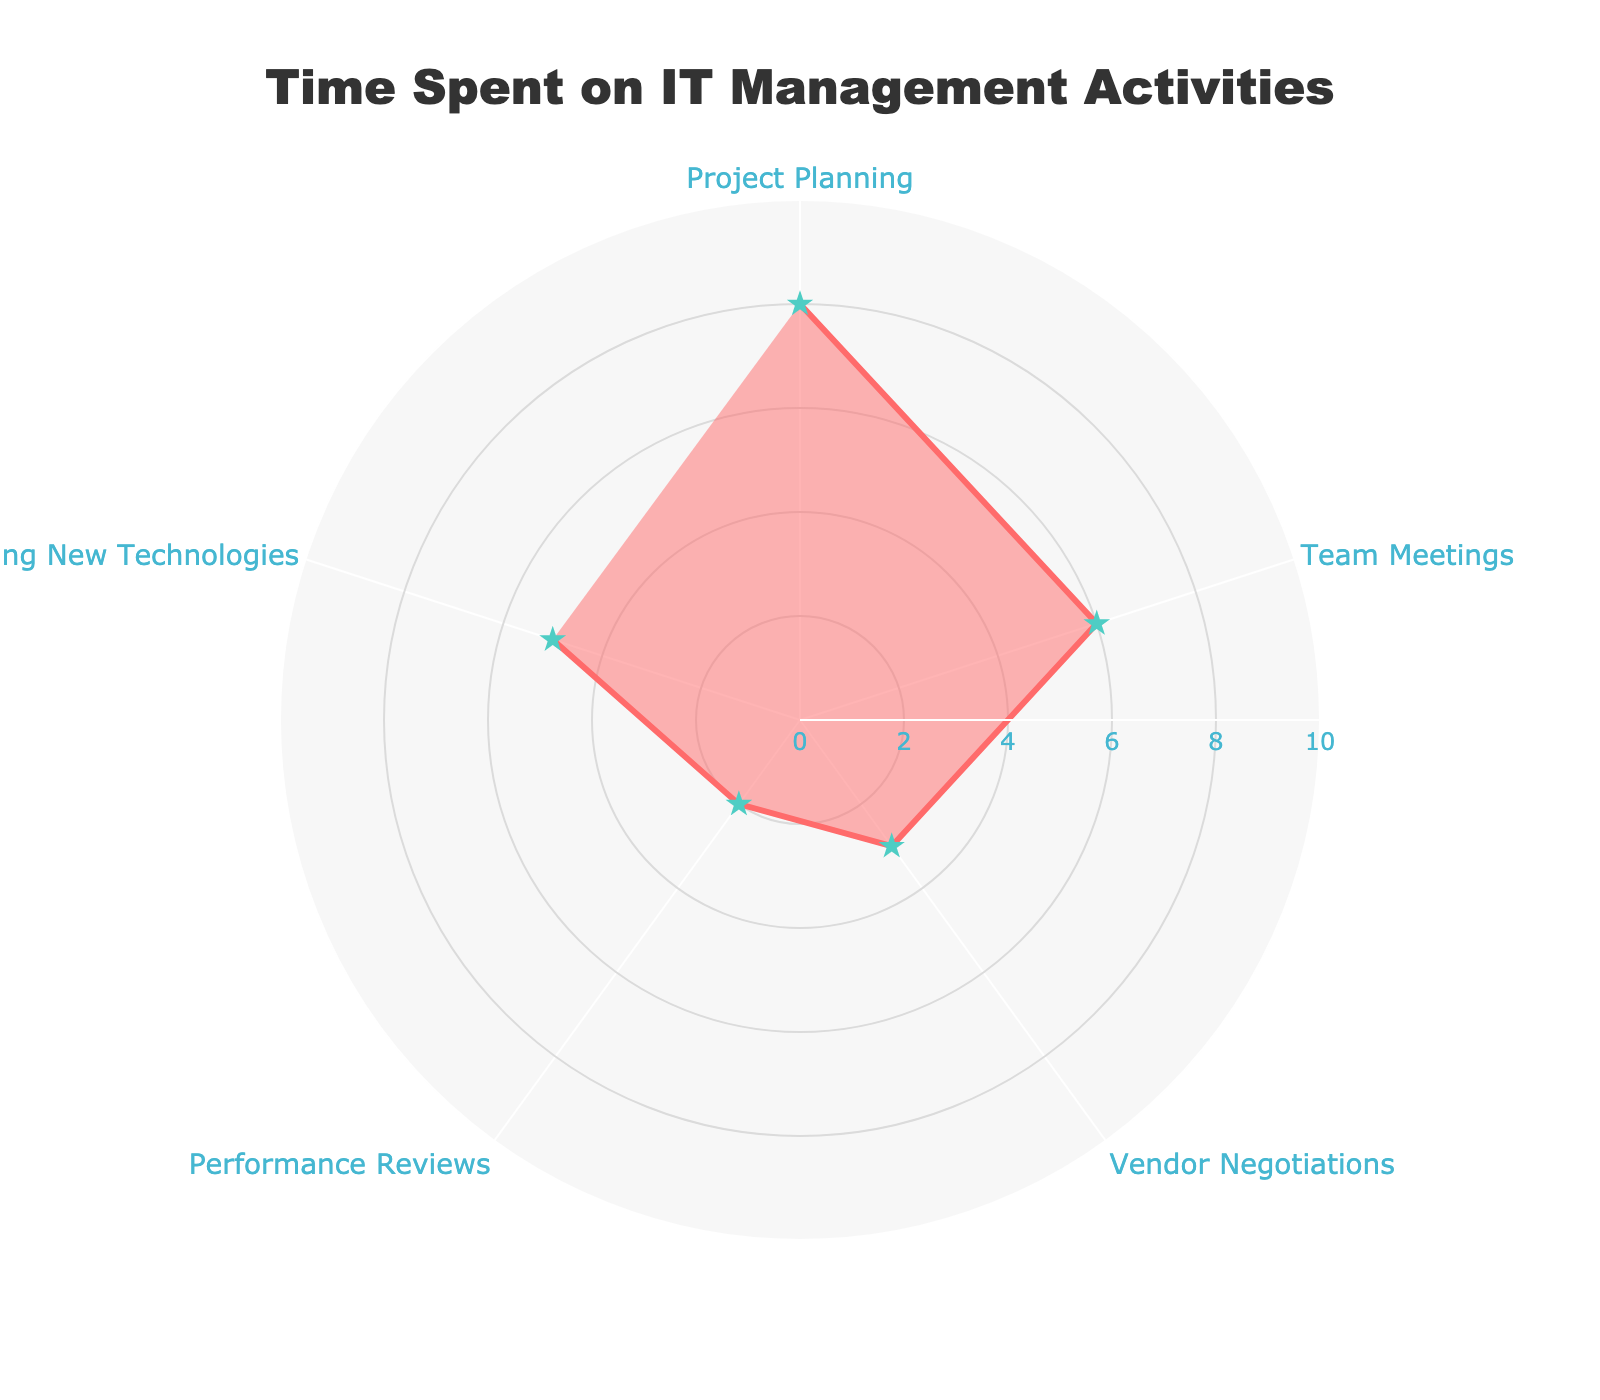What is the title of the radar chart? The title is positioned at the top center of the radar chart. It provides an overview of what the chart represents. By reading the title, we can quickly understand the context of the data displayed.
Answer: Time Spent on IT Management Activities What activity has the highest time spent per week? By looking at the values around the radar chart, you can identify which activity has the largest value. It should be the point reaching the furthest from the center.
Answer: Project Planning What is the range of the radial axis in the chart? The radial axis range is visible on the chart, showing the minimum and maximum values that can be represented.
Answer: 0 to 10 Which two activities have a combined total time spent of 14 hours per week? Find two sections of the radar chart where the sum of their values equals 14. You can do this by examining the individual values and mentally adding them together.
Answer: Project Planning and Team Meetings How much more time do you spend on Project Planning compared to Vendor Negotiations? Subtract the value of Vendor Negotiations from the value of Project Planning. This involves comparing the lengths of the corresponding segments on the radar chart.
Answer: 5 hours Which activity do you spend the least amount of time on? Identify the shortest segment or the point closest to the center of the radar chart. This represents the activity with the lowest value.
Answer: Performance Reviews What is the total time spent on Team Meetings and Researching New Technologies combined? Add the value of the time spent on Team Meetings to the value of the time spent on Researching New Technologies. These values can be found along the corresponding segments of the radar chart.
Answer: 11 hours What is the average time spent on all activities per week? Sum up the time spent on all activities and divide by the number of activities. This requires finding the total sum and then performing the division.
Answer: 4.8 hours Which activity's time spent is closest to the average time spent across all activities? After calculating the average time (4.8 hours), compare each activity's time spent to this average to determine which is closest.
Answer: Researching New Technologies How many hours per week do you spend on Vendor Negotiations and Performance Reviews combined? Add the values of Vendor Negotiations and Performance Reviews together to get the combined total.
Answer: 5 hours 